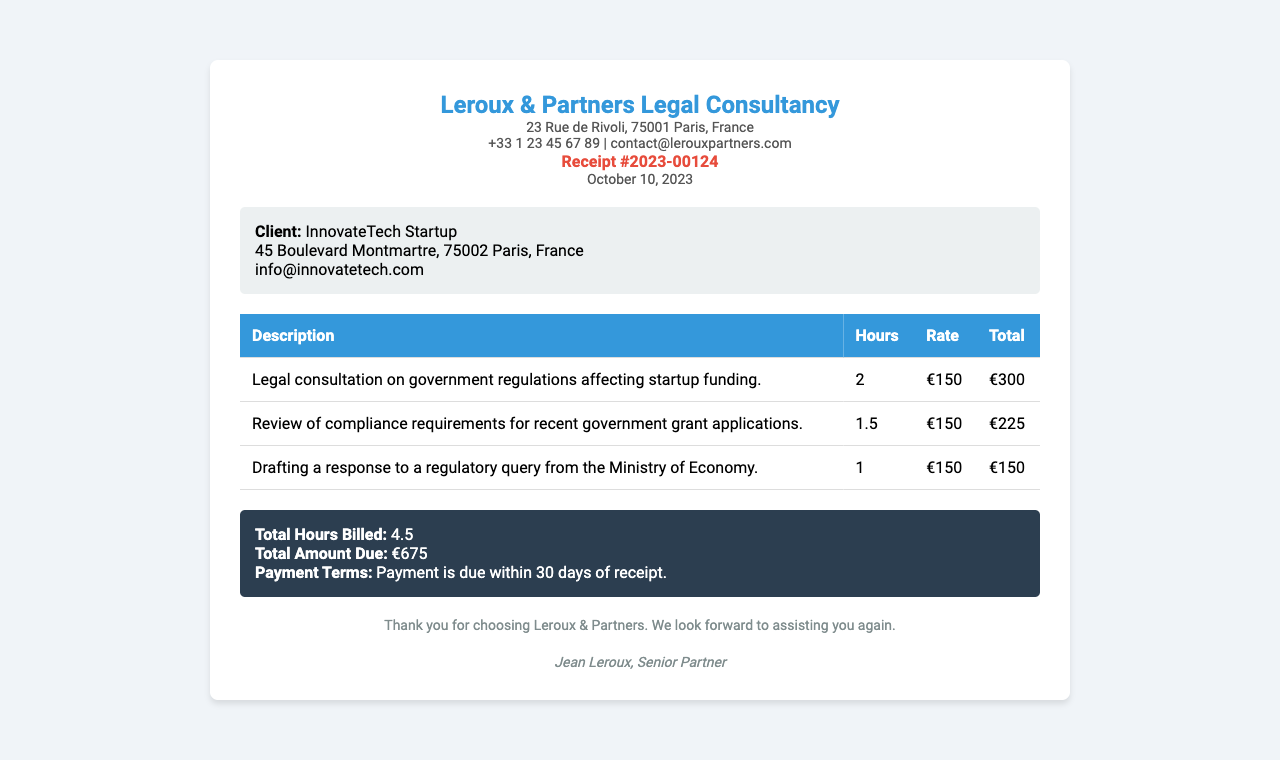What is the receipt number? The receipt number is indicated clearly in the document to identify this specific consultation.
Answer: Receipt #2023-00124 What is the total amount due? The total amount due is calculated from the services rendered in the consultation.
Answer: €675 Who is the client? The client is mentioned at the beginning of the client information section of the receipt.
Answer: InnovateTech Startup What is the date of the receipt? The date of the receipt indicates when the service was rendered and is crucial for payment terms.
Answer: October 10, 2023 How many hours were billed in total? The total hours billed is summarized in the receipt's summary section.
Answer: 4.5 What was the rate per hour for the legal consultation? The rate per hour is provided in the breakdown of services rendered table in the receipt.
Answer: €150 Which regulatory body was queried in the drafting of the response? The regulatory body is mentioned specifically in the description of one of the services rendered.
Answer: Ministry of Economy What is the payment term for the consultation fee? The payment term is outlined in the summary section of the receipt, which specifies when payment is expected.
Answer: Payment is due within 30 days of receipt How many services were provided in total? The services provided are listed in the table which breaks down the consultations conducted.
Answer: 3 